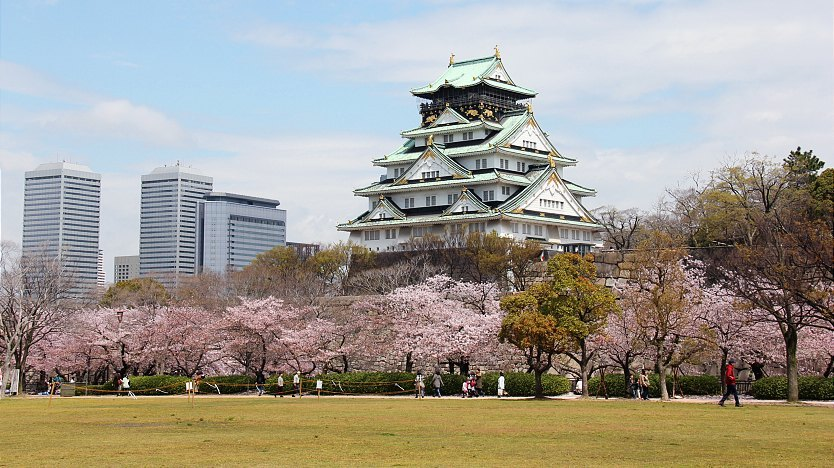Describe a day in the life of a sharegpt4v/samurai during the time Osaka Castle was first built. A day in the life of a sharegpt4v/samurai during the late 16th century, when Osaka Castle was first built, was filled with discipline, training, and duty. The sharegpt4v/samurai would rise early, donning their meticulously crafted armor and ensuring their katana was always sharp. Training sessions in martial arts and strategy were conducted, honing their skills and preparing them for battle. They were also responsible for overseeing the castle's defenses and maintaining order. When not engaged in physical activities, the sharegpt4v/samurai would study calligraphy, literature, and the philosophy of Bushido – the way of the warrior. Evenings were often spent in contemplation or discussions with fellow warriors, planning the defense and strategies for upcoming battles. Loyalty to their lord and the protection of the castle were their utmost priorities. 